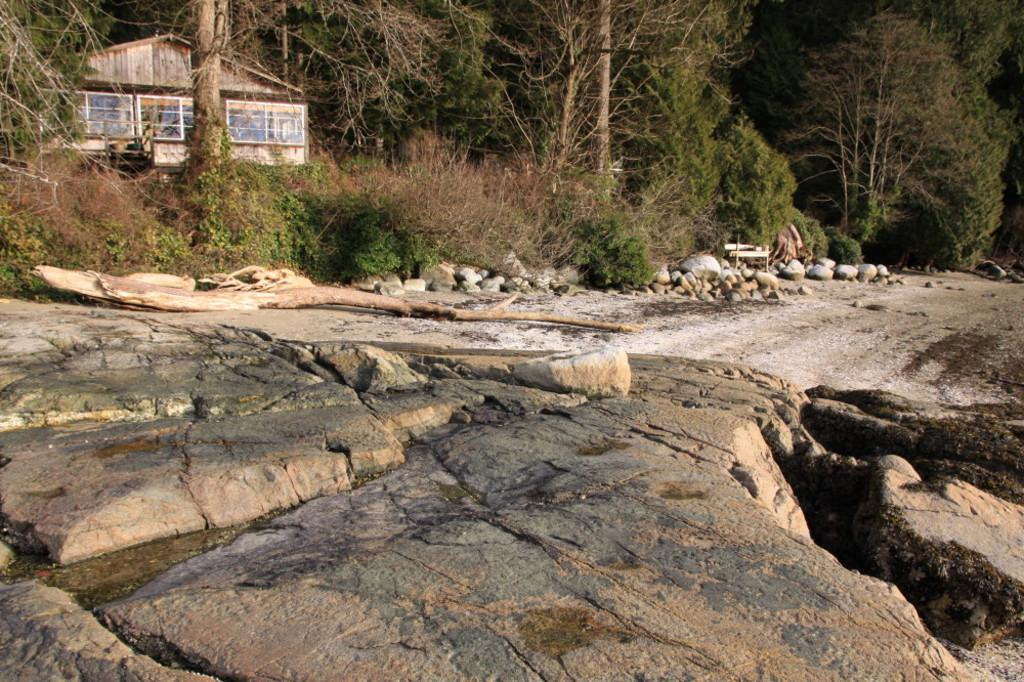What is the main feature of the image? There is a huge rock surface in the image. What other objects can be seen on the rock surface? There are stones and wooden logs on the rock surface. What type of vegetation is present in the image? There are trees in the image. What structure is visible in the background? There is a house in the background of the image. What material is the house made of? The house is made of wood. What is the color of the background in the image? The background of the image is black. What type of thrill can be experienced by the duck in the image? There is no duck present in the image, so it cannot be determined if any thrill is experienced. 